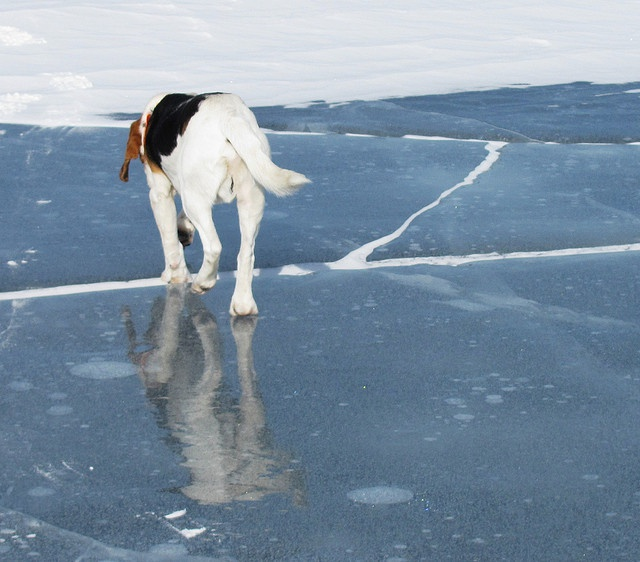Describe the objects in this image and their specific colors. I can see a dog in lightgray, black, darkgray, and gray tones in this image. 